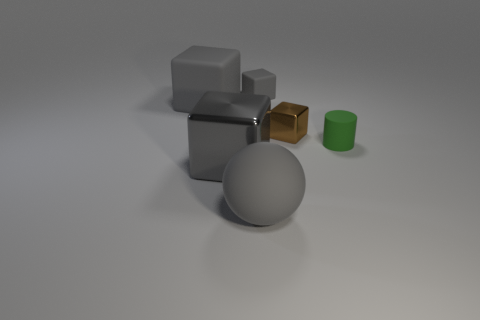The tiny thing that is behind the large gray rubber thing behind the green rubber object is made of what material?
Give a very brief answer. Rubber. Do the gray block in front of the brown object and the green cylinder have the same material?
Offer a very short reply. No. There is a gray block to the right of the large shiny block; what size is it?
Keep it short and to the point. Small. Are there any gray cubes that are in front of the large block that is in front of the matte cylinder?
Provide a short and direct response. No. There is a cube that is to the right of the tiny gray cube; is its color the same as the big rubber object on the right side of the gray shiny block?
Provide a succinct answer. No. The big metallic object has what color?
Provide a short and direct response. Gray. Is there anything else that is the same color as the large matte sphere?
Keep it short and to the point. Yes. What is the color of the block that is both in front of the tiny gray rubber block and on the right side of the gray rubber ball?
Your response must be concise. Brown. There is a metal object in front of the green rubber object; is it the same size as the small gray block?
Offer a terse response. No. Are there more small gray rubber cubes that are in front of the small metallic thing than gray blocks?
Your response must be concise. No. 